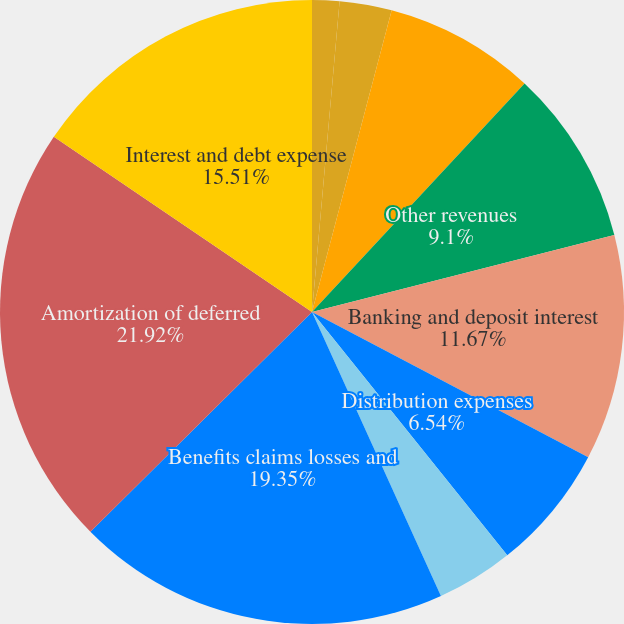<chart> <loc_0><loc_0><loc_500><loc_500><pie_chart><fcel>Management and financial<fcel>Distribution fees<fcel>Net investment income<fcel>Other revenues<fcel>Banking and deposit interest<fcel>Distribution expenses<fcel>Interest credited to fixed<fcel>Benefits claims losses and<fcel>Amortization of deferred<fcel>Interest and debt expense<nl><fcel>1.41%<fcel>2.7%<fcel>7.82%<fcel>9.1%<fcel>11.67%<fcel>6.54%<fcel>3.98%<fcel>19.35%<fcel>21.92%<fcel>15.51%<nl></chart> 